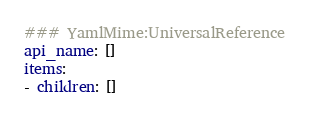<code> <loc_0><loc_0><loc_500><loc_500><_YAML_>### YamlMime:UniversalReference
api_name: []
items:
- children: []</code> 